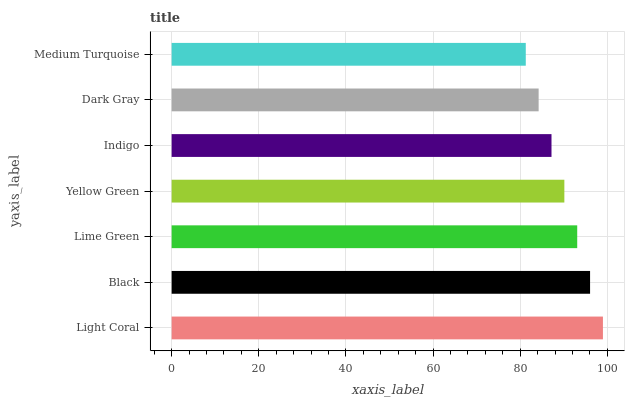Is Medium Turquoise the minimum?
Answer yes or no. Yes. Is Light Coral the maximum?
Answer yes or no. Yes. Is Black the minimum?
Answer yes or no. No. Is Black the maximum?
Answer yes or no. No. Is Light Coral greater than Black?
Answer yes or no. Yes. Is Black less than Light Coral?
Answer yes or no. Yes. Is Black greater than Light Coral?
Answer yes or no. No. Is Light Coral less than Black?
Answer yes or no. No. Is Yellow Green the high median?
Answer yes or no. Yes. Is Yellow Green the low median?
Answer yes or no. Yes. Is Light Coral the high median?
Answer yes or no. No. Is Lime Green the low median?
Answer yes or no. No. 